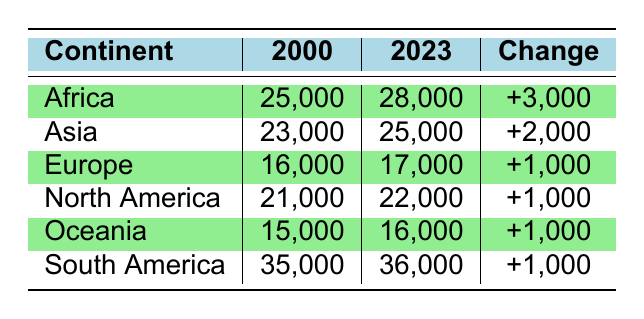What was the species richness in Africa in 2000? In the table, under the Africa row for the year 2000, the species richness is listed as 25,000.
Answer: 25,000 How many species were recorded in Asia in 2023? In the table, looking at the Asia row for the year 2023, it shows that the species richness is 25,000.
Answer: 25,000 Which continent had the highest species richness in 2000? By comparing the species richness values for all continents in 2000, South America has the highest at 35,000.
Answer: South America What is the total change in species richness for North America from 2000 to 2023? For North America, the species richness increased from 21,000 in 2000 to 22,000 in 2023. The change is calculated as 22,000 - 21,000 = 1,000.
Answer: 1,000 Is it true that species richness in Europe increased from 2000 to 2023? Yes, in the table, Europe shows an increase from 16,000 in 2000 to 17,000 in 2023, confirming that the species richness did increase.
Answer: Yes Which continents experienced a species richness increase greater than 1,000? Africa and Asia experienced increases of 3,000 and 2,000 respectively, which are both greater than 1,000 according to the table's change column.
Answer: Africa and Asia What is the average species richness for all continents in 2023? We add the species richness for all continents in 2023: 28,000 (Africa) + 25,000 (Asia) + 17,000 (Europe) + 22,000 (North America) + 16,000 (Oceania) + 36,000 (South America) = 144,000. There are 6 continents, so we divide 144,000 by 6 to find the average, which is 24,000.
Answer: 24,000 By how much did species richness in Oceania increase from 2000 to 2023? For Oceania, the species richness was 15,000 in 2000 and rose to 16,000 in 2023. The increase is calculated as 16,000 - 15,000 = 1,000.
Answer: 1,000 Is the statement "Asia had less species richness than Europe in 2023" true? In 2023, Asia has a species richness of 25,000 while Europe has 17,000. Thus, the statement is false because Asia has more species richness than Europe.
Answer: No 